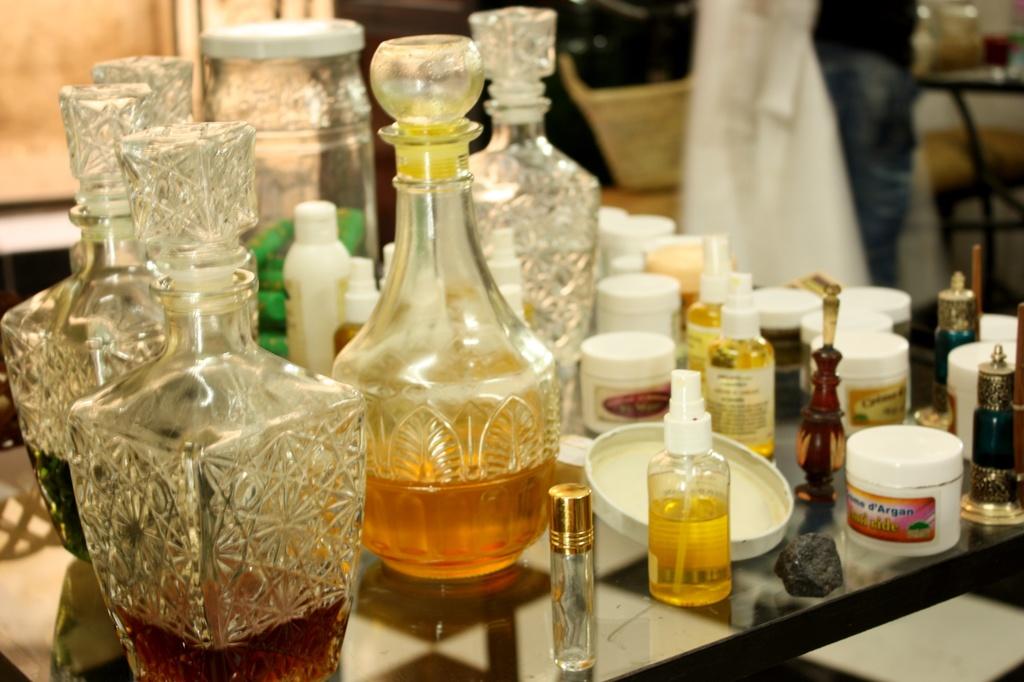What color is the liquid in the tiny spray bottle?
Provide a succinct answer. Yellow. 